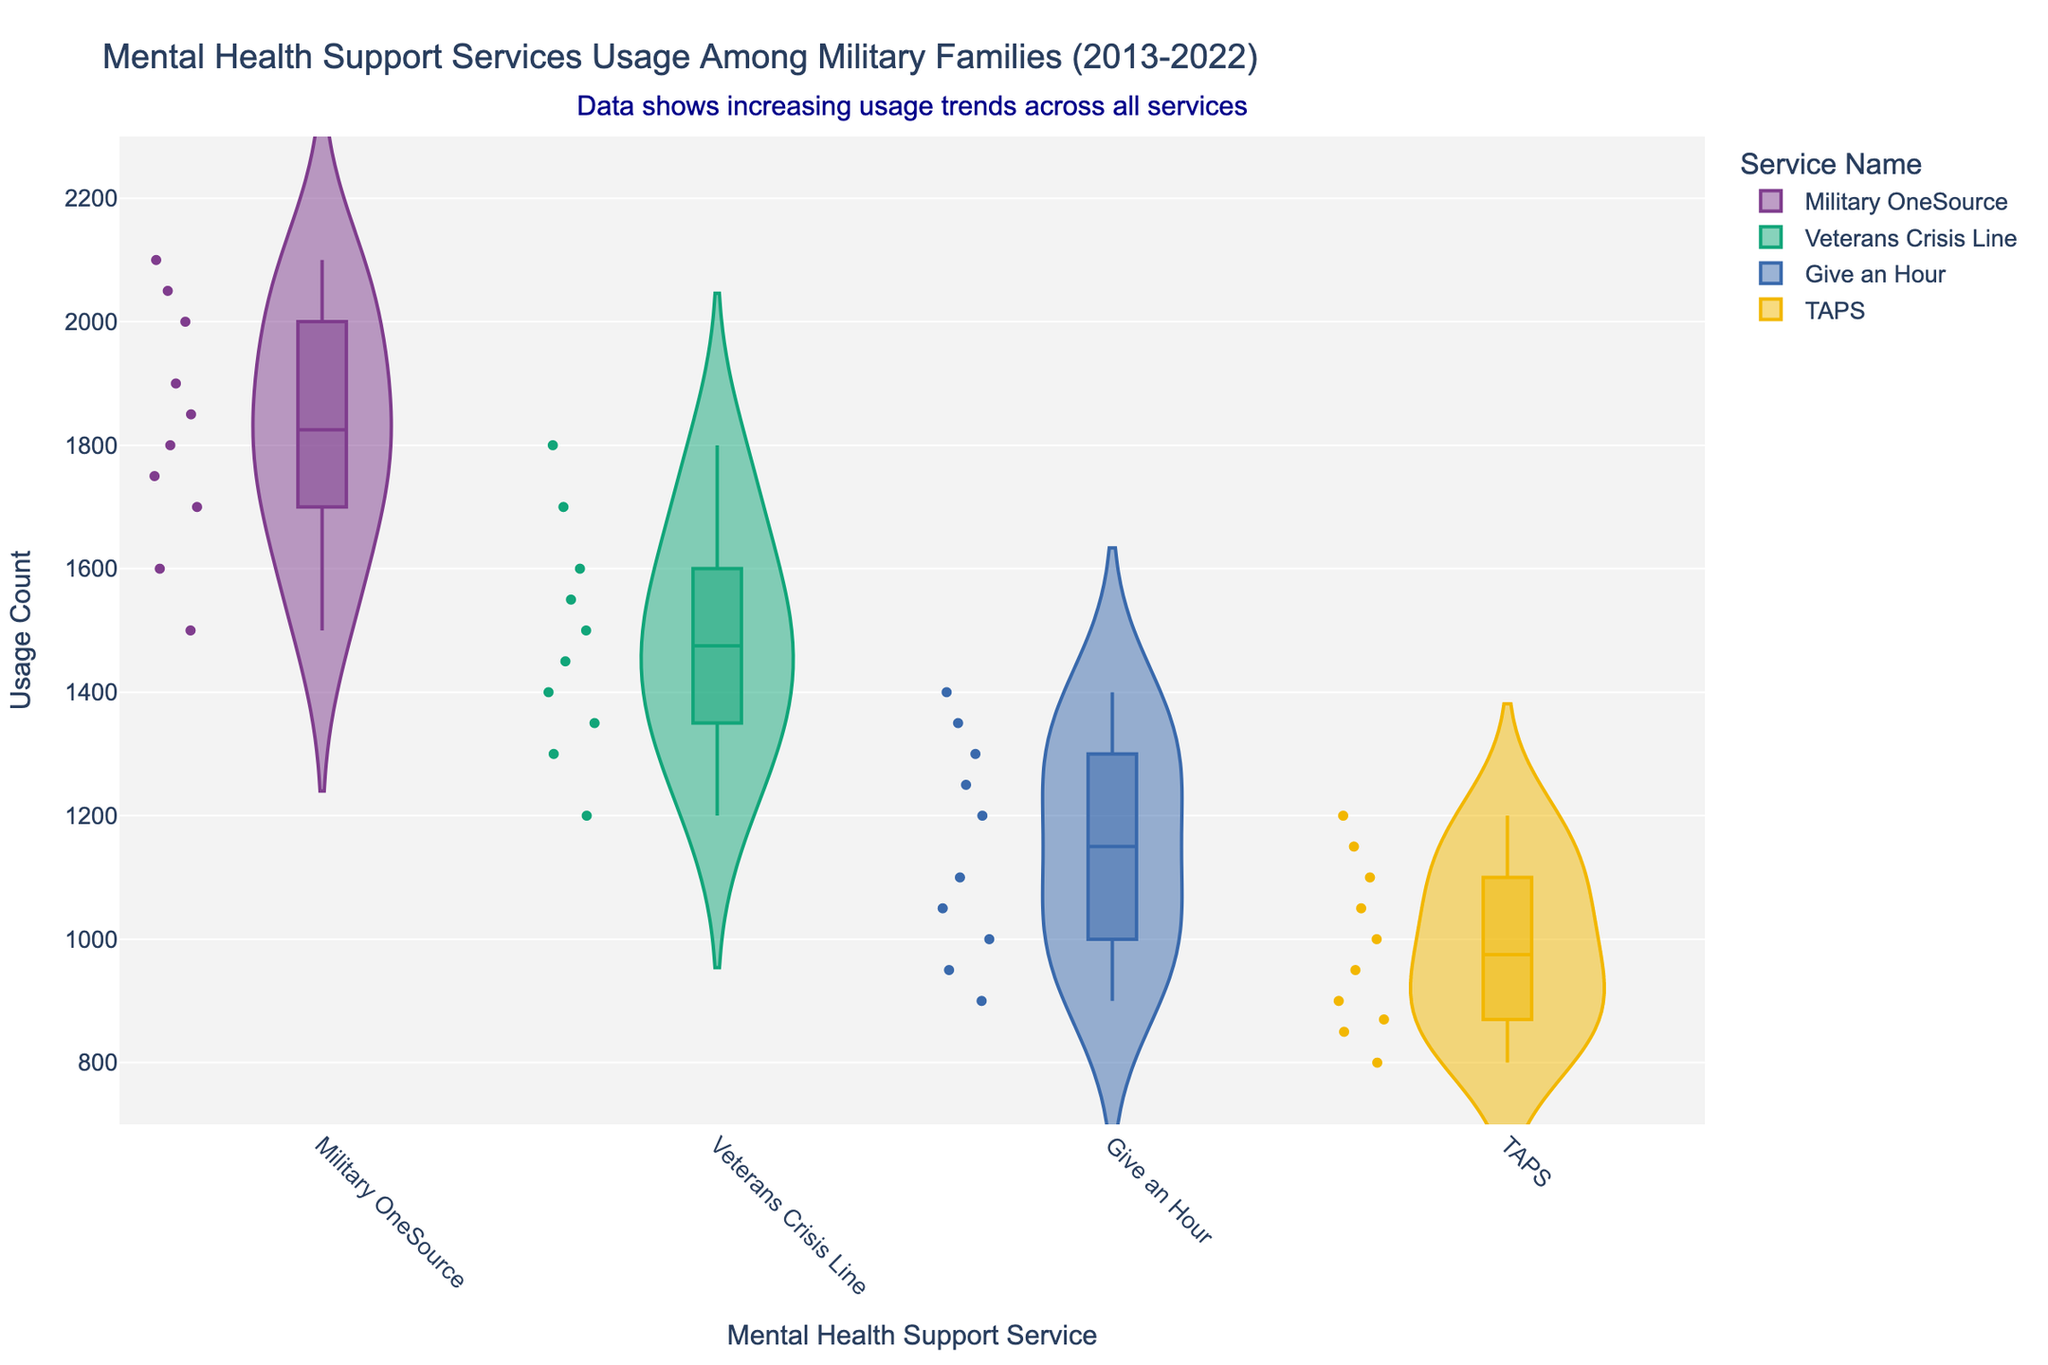What is the title of the figure? The title is usually found at the top of the chart. Here, it reads "Mental Health Support Services Usage Among Military Families (2013-2022)".
Answer: Mental Health Support Services Usage Among Military Families (2013-2022) How many mental health support services are displayed in the figure? You can count the distinct colors or service names displayed along the x-axis. There are four services shown: Military OneSource, Veterans Crisis Line, Give an Hour, and TAPS.
Answer: 4 Which mental health support service has the highest usage count? Look for the highest points on the y-axis across all the services. Military OneSource has the highest usage count of 2100.
Answer: Military OneSource What is the range of usage counts for Give an Hour? Identify the lowest and highest points of the violin plot for Give an Hour. The range is from 900 to 1400.
Answer: 900 to 1400 Which year shows the highest usage for Veterans Crisis Line? Find the year corresponding to the highest point within the violin plot for Veterans Crisis Line. The highest usage is in 2022 with a count of 1800.
Answer: 2022 What is the median usage count for TAPS? Violin plots often include a box plot which shows the median as a horizontal line. For TAPS, the median usage count appears to be around 950.
Answer: ~950 Which service has the most variability in usage counts? The width of the violin plot reflects variability. "Give an Hour" shows the widest distribution, indicating the most variability in usage counts.
Answer: Give an Hour Are there any overlapping usage counts between Military OneSource and Veterans Crisis Line? Look for areas where the violin plots overlap on the y-axis. Both services have usage counts ranging between 1200 and 1800.
Answer: Yes What trend does the data suggest about overall usage of these services? The data suggests increasing usage trends over the years across all services, indicated by the rising usage counts over time.
Answer: Increasing usage trends 